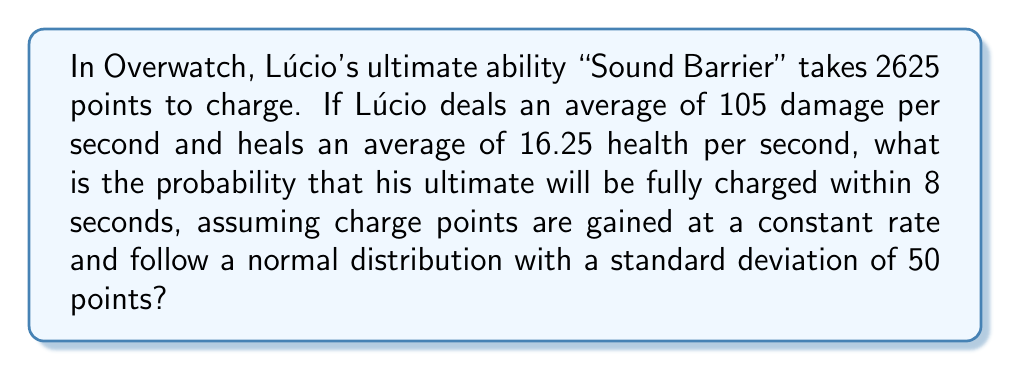Teach me how to tackle this problem. Let's approach this step-by-step:

1) First, calculate the average charge rate per second:
   $$\text{Charge rate} = 105 + 16.25 = 121.25 \text{ points/second}$$

2) Calculate the expected charge after 8 seconds:
   $$\text{Expected charge} = 121.25 \times 8 = 970 \text{ points}$$

3) The question is asking for the probability of charging 2625 points within 8 seconds.

4) We're told that the charge points follow a normal distribution with a standard deviation of 50 points.

5) To find the probability, we need to calculate the z-score:

   $$z = \frac{\text{Required value} - \text{Mean}}{\text{Standard deviation}}$$

   $$z = \frac{2625 - 970}{50} = 33.1$$

6) This z-score is extremely high, indicating that the probability is very close to 0.

7) Using a standard normal distribution table or calculator, we find:

   $$P(Z > 33.1) \approx 0$$

8) Therefore, the probability of Lúcio's ultimate charging within 8 seconds is essentially 0.
Answer: $\approx 0$ 